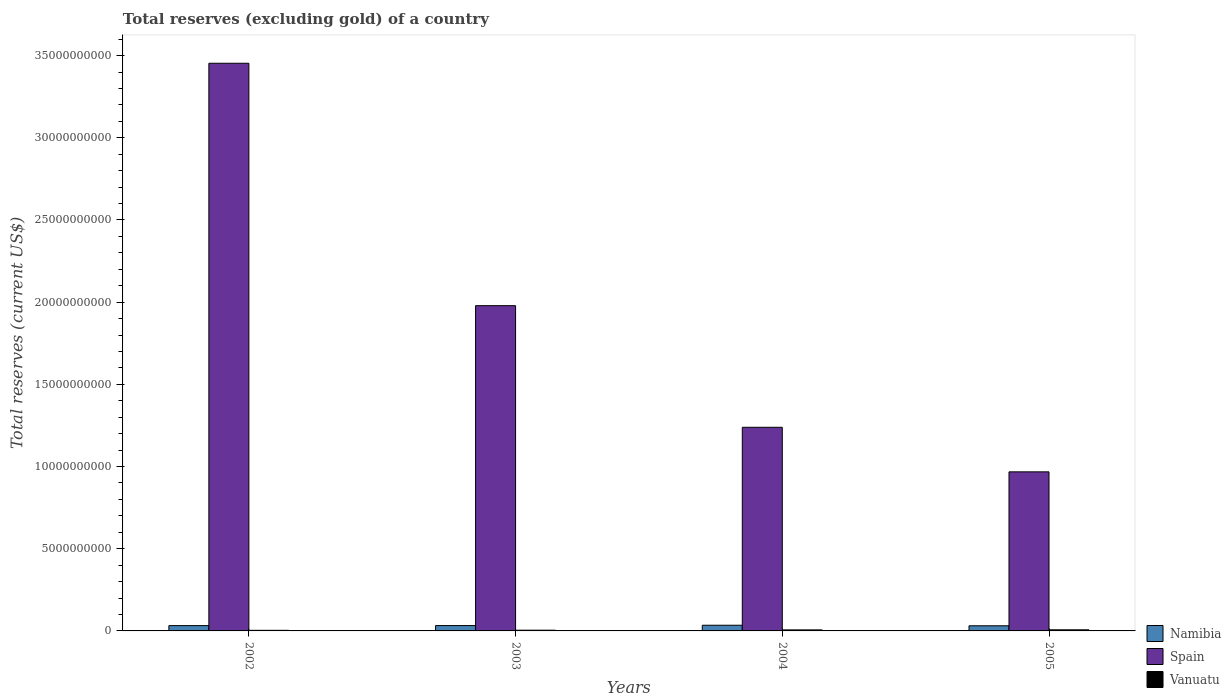Are the number of bars per tick equal to the number of legend labels?
Your answer should be compact. Yes. Are the number of bars on each tick of the X-axis equal?
Provide a short and direct response. Yes. How many bars are there on the 2nd tick from the left?
Keep it short and to the point. 3. How many bars are there on the 2nd tick from the right?
Give a very brief answer. 3. In how many cases, is the number of bars for a given year not equal to the number of legend labels?
Ensure brevity in your answer.  0. What is the total reserves (excluding gold) in Spain in 2002?
Offer a terse response. 3.45e+1. Across all years, what is the maximum total reserves (excluding gold) in Vanuatu?
Offer a very short reply. 6.72e+07. Across all years, what is the minimum total reserves (excluding gold) in Vanuatu?
Ensure brevity in your answer.  3.65e+07. In which year was the total reserves (excluding gold) in Vanuatu maximum?
Ensure brevity in your answer.  2005. What is the total total reserves (excluding gold) in Namibia in the graph?
Offer a terse response. 1.31e+09. What is the difference between the total reserves (excluding gold) in Spain in 2002 and that in 2005?
Provide a short and direct response. 2.49e+1. What is the difference between the total reserves (excluding gold) in Spain in 2003 and the total reserves (excluding gold) in Vanuatu in 2002?
Ensure brevity in your answer.  1.98e+1. What is the average total reserves (excluding gold) in Spain per year?
Keep it short and to the point. 1.91e+1. In the year 2002, what is the difference between the total reserves (excluding gold) in Vanuatu and total reserves (excluding gold) in Namibia?
Keep it short and to the point. -2.87e+08. What is the ratio of the total reserves (excluding gold) in Spain in 2002 to that in 2005?
Your answer should be very brief. 3.57. What is the difference between the highest and the second highest total reserves (excluding gold) in Namibia?
Offer a very short reply. 1.98e+07. What is the difference between the highest and the lowest total reserves (excluding gold) in Vanuatu?
Your answer should be very brief. 3.07e+07. What does the 3rd bar from the left in 2005 represents?
Provide a short and direct response. Vanuatu. What does the 1st bar from the right in 2002 represents?
Your response must be concise. Vanuatu. Is it the case that in every year, the sum of the total reserves (excluding gold) in Vanuatu and total reserves (excluding gold) in Spain is greater than the total reserves (excluding gold) in Namibia?
Ensure brevity in your answer.  Yes. How many bars are there?
Your answer should be compact. 12. What is the difference between two consecutive major ticks on the Y-axis?
Your answer should be very brief. 5.00e+09. Are the values on the major ticks of Y-axis written in scientific E-notation?
Keep it short and to the point. No. Where does the legend appear in the graph?
Your response must be concise. Bottom right. How many legend labels are there?
Keep it short and to the point. 3. What is the title of the graph?
Your answer should be very brief. Total reserves (excluding gold) of a country. Does "Tajikistan" appear as one of the legend labels in the graph?
Your answer should be compact. No. What is the label or title of the Y-axis?
Keep it short and to the point. Total reserves (current US$). What is the Total reserves (current US$) in Namibia in 2002?
Make the answer very short. 3.23e+08. What is the Total reserves (current US$) in Spain in 2002?
Provide a short and direct response. 3.45e+1. What is the Total reserves (current US$) in Vanuatu in 2002?
Give a very brief answer. 3.65e+07. What is the Total reserves (current US$) in Namibia in 2003?
Provide a short and direct response. 3.25e+08. What is the Total reserves (current US$) in Spain in 2003?
Offer a very short reply. 1.98e+1. What is the Total reserves (current US$) of Vanuatu in 2003?
Keep it short and to the point. 4.38e+07. What is the Total reserves (current US$) of Namibia in 2004?
Your answer should be very brief. 3.45e+08. What is the Total reserves (current US$) in Spain in 2004?
Offer a terse response. 1.24e+1. What is the Total reserves (current US$) in Vanuatu in 2004?
Provide a short and direct response. 6.18e+07. What is the Total reserves (current US$) of Namibia in 2005?
Your answer should be compact. 3.12e+08. What is the Total reserves (current US$) in Spain in 2005?
Provide a short and direct response. 9.68e+09. What is the Total reserves (current US$) in Vanuatu in 2005?
Ensure brevity in your answer.  6.72e+07. Across all years, what is the maximum Total reserves (current US$) in Namibia?
Offer a terse response. 3.45e+08. Across all years, what is the maximum Total reserves (current US$) in Spain?
Ensure brevity in your answer.  3.45e+1. Across all years, what is the maximum Total reserves (current US$) in Vanuatu?
Offer a very short reply. 6.72e+07. Across all years, what is the minimum Total reserves (current US$) in Namibia?
Keep it short and to the point. 3.12e+08. Across all years, what is the minimum Total reserves (current US$) in Spain?
Offer a very short reply. 9.68e+09. Across all years, what is the minimum Total reserves (current US$) in Vanuatu?
Your answer should be very brief. 3.65e+07. What is the total Total reserves (current US$) of Namibia in the graph?
Your answer should be compact. 1.31e+09. What is the total Total reserves (current US$) in Spain in the graph?
Your answer should be compact. 7.64e+1. What is the total Total reserves (current US$) in Vanuatu in the graph?
Give a very brief answer. 2.09e+08. What is the difference between the Total reserves (current US$) in Namibia in 2002 and that in 2003?
Keep it short and to the point. -2.08e+06. What is the difference between the Total reserves (current US$) in Spain in 2002 and that in 2003?
Offer a very short reply. 1.47e+1. What is the difference between the Total reserves (current US$) of Vanuatu in 2002 and that in 2003?
Make the answer very short. -7.29e+06. What is the difference between the Total reserves (current US$) of Namibia in 2002 and that in 2004?
Provide a short and direct response. -2.19e+07. What is the difference between the Total reserves (current US$) of Spain in 2002 and that in 2004?
Ensure brevity in your answer.  2.21e+1. What is the difference between the Total reserves (current US$) of Vanuatu in 2002 and that in 2004?
Give a very brief answer. -2.53e+07. What is the difference between the Total reserves (current US$) in Namibia in 2002 and that in 2005?
Provide a short and direct response. 1.10e+07. What is the difference between the Total reserves (current US$) of Spain in 2002 and that in 2005?
Your answer should be very brief. 2.49e+1. What is the difference between the Total reserves (current US$) in Vanuatu in 2002 and that in 2005?
Offer a terse response. -3.07e+07. What is the difference between the Total reserves (current US$) of Namibia in 2003 and that in 2004?
Ensure brevity in your answer.  -1.98e+07. What is the difference between the Total reserves (current US$) in Spain in 2003 and that in 2004?
Ensure brevity in your answer.  7.40e+09. What is the difference between the Total reserves (current US$) of Vanuatu in 2003 and that in 2004?
Your answer should be compact. -1.80e+07. What is the difference between the Total reserves (current US$) in Namibia in 2003 and that in 2005?
Provide a short and direct response. 1.31e+07. What is the difference between the Total reserves (current US$) of Spain in 2003 and that in 2005?
Your answer should be compact. 1.01e+1. What is the difference between the Total reserves (current US$) in Vanuatu in 2003 and that in 2005?
Provide a short and direct response. -2.34e+07. What is the difference between the Total reserves (current US$) in Namibia in 2004 and that in 2005?
Your answer should be very brief. 3.30e+07. What is the difference between the Total reserves (current US$) in Spain in 2004 and that in 2005?
Provide a succinct answer. 2.71e+09. What is the difference between the Total reserves (current US$) of Vanuatu in 2004 and that in 2005?
Offer a terse response. -5.38e+06. What is the difference between the Total reserves (current US$) in Namibia in 2002 and the Total reserves (current US$) in Spain in 2003?
Your response must be concise. -1.95e+1. What is the difference between the Total reserves (current US$) of Namibia in 2002 and the Total reserves (current US$) of Vanuatu in 2003?
Provide a succinct answer. 2.79e+08. What is the difference between the Total reserves (current US$) of Spain in 2002 and the Total reserves (current US$) of Vanuatu in 2003?
Keep it short and to the point. 3.45e+1. What is the difference between the Total reserves (current US$) of Namibia in 2002 and the Total reserves (current US$) of Spain in 2004?
Your answer should be very brief. -1.21e+1. What is the difference between the Total reserves (current US$) in Namibia in 2002 and the Total reserves (current US$) in Vanuatu in 2004?
Your answer should be compact. 2.61e+08. What is the difference between the Total reserves (current US$) of Spain in 2002 and the Total reserves (current US$) of Vanuatu in 2004?
Your answer should be very brief. 3.45e+1. What is the difference between the Total reserves (current US$) of Namibia in 2002 and the Total reserves (current US$) of Spain in 2005?
Offer a very short reply. -9.35e+09. What is the difference between the Total reserves (current US$) in Namibia in 2002 and the Total reserves (current US$) in Vanuatu in 2005?
Offer a terse response. 2.56e+08. What is the difference between the Total reserves (current US$) in Spain in 2002 and the Total reserves (current US$) in Vanuatu in 2005?
Give a very brief answer. 3.45e+1. What is the difference between the Total reserves (current US$) of Namibia in 2003 and the Total reserves (current US$) of Spain in 2004?
Provide a succinct answer. -1.21e+1. What is the difference between the Total reserves (current US$) of Namibia in 2003 and the Total reserves (current US$) of Vanuatu in 2004?
Offer a terse response. 2.63e+08. What is the difference between the Total reserves (current US$) of Spain in 2003 and the Total reserves (current US$) of Vanuatu in 2004?
Provide a succinct answer. 1.97e+1. What is the difference between the Total reserves (current US$) in Namibia in 2003 and the Total reserves (current US$) in Spain in 2005?
Offer a very short reply. -9.35e+09. What is the difference between the Total reserves (current US$) in Namibia in 2003 and the Total reserves (current US$) in Vanuatu in 2005?
Ensure brevity in your answer.  2.58e+08. What is the difference between the Total reserves (current US$) in Spain in 2003 and the Total reserves (current US$) in Vanuatu in 2005?
Your answer should be very brief. 1.97e+1. What is the difference between the Total reserves (current US$) of Namibia in 2004 and the Total reserves (current US$) of Spain in 2005?
Keep it short and to the point. -9.33e+09. What is the difference between the Total reserves (current US$) of Namibia in 2004 and the Total reserves (current US$) of Vanuatu in 2005?
Offer a very short reply. 2.78e+08. What is the difference between the Total reserves (current US$) in Spain in 2004 and the Total reserves (current US$) in Vanuatu in 2005?
Your response must be concise. 1.23e+1. What is the average Total reserves (current US$) of Namibia per year?
Offer a very short reply. 3.26e+08. What is the average Total reserves (current US$) of Spain per year?
Your answer should be very brief. 1.91e+1. What is the average Total reserves (current US$) in Vanuatu per year?
Offer a very short reply. 5.23e+07. In the year 2002, what is the difference between the Total reserves (current US$) in Namibia and Total reserves (current US$) in Spain?
Offer a very short reply. -3.42e+1. In the year 2002, what is the difference between the Total reserves (current US$) of Namibia and Total reserves (current US$) of Vanuatu?
Your response must be concise. 2.87e+08. In the year 2002, what is the difference between the Total reserves (current US$) of Spain and Total reserves (current US$) of Vanuatu?
Ensure brevity in your answer.  3.45e+1. In the year 2003, what is the difference between the Total reserves (current US$) of Namibia and Total reserves (current US$) of Spain?
Your response must be concise. -1.95e+1. In the year 2003, what is the difference between the Total reserves (current US$) of Namibia and Total reserves (current US$) of Vanuatu?
Provide a succinct answer. 2.81e+08. In the year 2003, what is the difference between the Total reserves (current US$) in Spain and Total reserves (current US$) in Vanuatu?
Keep it short and to the point. 1.97e+1. In the year 2004, what is the difference between the Total reserves (current US$) of Namibia and Total reserves (current US$) of Spain?
Provide a short and direct response. -1.20e+1. In the year 2004, what is the difference between the Total reserves (current US$) in Namibia and Total reserves (current US$) in Vanuatu?
Your answer should be very brief. 2.83e+08. In the year 2004, what is the difference between the Total reserves (current US$) in Spain and Total reserves (current US$) in Vanuatu?
Offer a terse response. 1.23e+1. In the year 2005, what is the difference between the Total reserves (current US$) in Namibia and Total reserves (current US$) in Spain?
Your answer should be compact. -9.37e+09. In the year 2005, what is the difference between the Total reserves (current US$) in Namibia and Total reserves (current US$) in Vanuatu?
Give a very brief answer. 2.45e+08. In the year 2005, what is the difference between the Total reserves (current US$) of Spain and Total reserves (current US$) of Vanuatu?
Your answer should be compact. 9.61e+09. What is the ratio of the Total reserves (current US$) of Namibia in 2002 to that in 2003?
Keep it short and to the point. 0.99. What is the ratio of the Total reserves (current US$) of Spain in 2002 to that in 2003?
Provide a succinct answer. 1.75. What is the ratio of the Total reserves (current US$) of Vanuatu in 2002 to that in 2003?
Your answer should be very brief. 0.83. What is the ratio of the Total reserves (current US$) of Namibia in 2002 to that in 2004?
Your response must be concise. 0.94. What is the ratio of the Total reserves (current US$) of Spain in 2002 to that in 2004?
Offer a terse response. 2.79. What is the ratio of the Total reserves (current US$) in Vanuatu in 2002 to that in 2004?
Provide a succinct answer. 0.59. What is the ratio of the Total reserves (current US$) in Namibia in 2002 to that in 2005?
Your answer should be compact. 1.04. What is the ratio of the Total reserves (current US$) of Spain in 2002 to that in 2005?
Your response must be concise. 3.57. What is the ratio of the Total reserves (current US$) in Vanuatu in 2002 to that in 2005?
Your answer should be very brief. 0.54. What is the ratio of the Total reserves (current US$) of Namibia in 2003 to that in 2004?
Give a very brief answer. 0.94. What is the ratio of the Total reserves (current US$) of Spain in 2003 to that in 2004?
Ensure brevity in your answer.  1.6. What is the ratio of the Total reserves (current US$) of Vanuatu in 2003 to that in 2004?
Keep it short and to the point. 0.71. What is the ratio of the Total reserves (current US$) in Namibia in 2003 to that in 2005?
Provide a short and direct response. 1.04. What is the ratio of the Total reserves (current US$) of Spain in 2003 to that in 2005?
Keep it short and to the point. 2.04. What is the ratio of the Total reserves (current US$) in Vanuatu in 2003 to that in 2005?
Offer a terse response. 0.65. What is the ratio of the Total reserves (current US$) of Namibia in 2004 to that in 2005?
Your answer should be compact. 1.11. What is the ratio of the Total reserves (current US$) of Spain in 2004 to that in 2005?
Provide a succinct answer. 1.28. What is the ratio of the Total reserves (current US$) in Vanuatu in 2004 to that in 2005?
Your answer should be very brief. 0.92. What is the difference between the highest and the second highest Total reserves (current US$) in Namibia?
Your response must be concise. 1.98e+07. What is the difference between the highest and the second highest Total reserves (current US$) of Spain?
Ensure brevity in your answer.  1.47e+1. What is the difference between the highest and the second highest Total reserves (current US$) of Vanuatu?
Your answer should be very brief. 5.38e+06. What is the difference between the highest and the lowest Total reserves (current US$) of Namibia?
Keep it short and to the point. 3.30e+07. What is the difference between the highest and the lowest Total reserves (current US$) in Spain?
Offer a terse response. 2.49e+1. What is the difference between the highest and the lowest Total reserves (current US$) of Vanuatu?
Provide a succinct answer. 3.07e+07. 